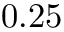<formula> <loc_0><loc_0><loc_500><loc_500>0 . 2 5</formula> 